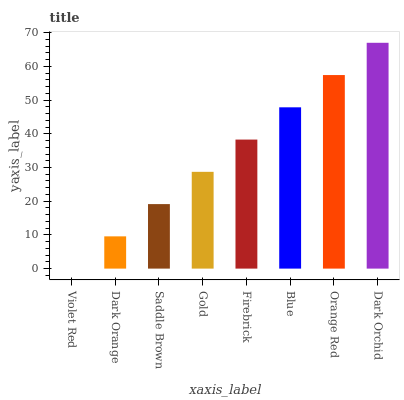Is Dark Orange the minimum?
Answer yes or no. No. Is Dark Orange the maximum?
Answer yes or no. No. Is Dark Orange greater than Violet Red?
Answer yes or no. Yes. Is Violet Red less than Dark Orange?
Answer yes or no. Yes. Is Violet Red greater than Dark Orange?
Answer yes or no. No. Is Dark Orange less than Violet Red?
Answer yes or no. No. Is Firebrick the high median?
Answer yes or no. Yes. Is Gold the low median?
Answer yes or no. Yes. Is Dark Orchid the high median?
Answer yes or no. No. Is Dark Orange the low median?
Answer yes or no. No. 